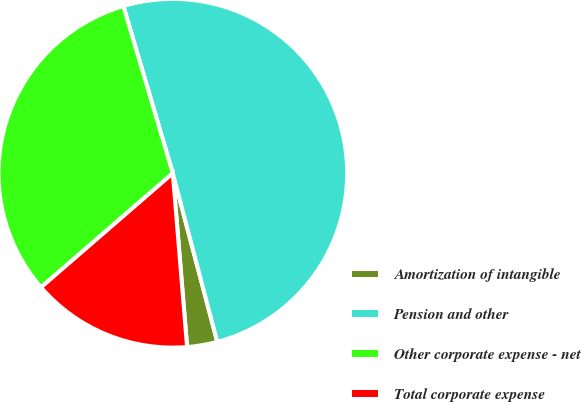Convert chart to OTSL. <chart><loc_0><loc_0><loc_500><loc_500><pie_chart><fcel>Amortization of intangible<fcel>Pension and other<fcel>Other corporate expense - net<fcel>Total corporate expense<nl><fcel>2.8%<fcel>50.47%<fcel>31.78%<fcel>14.95%<nl></chart> 